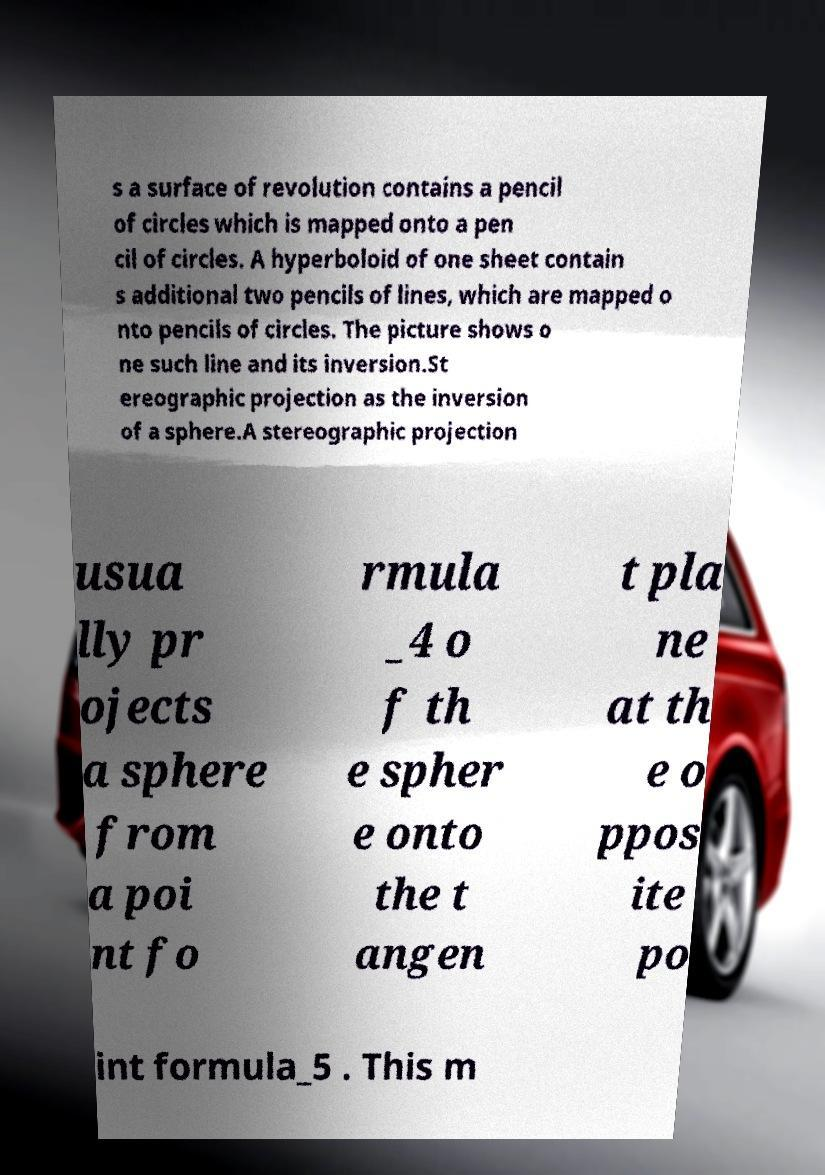What messages or text are displayed in this image? I need them in a readable, typed format. s a surface of revolution contains a pencil of circles which is mapped onto a pen cil of circles. A hyperboloid of one sheet contain s additional two pencils of lines, which are mapped o nto pencils of circles. The picture shows o ne such line and its inversion.St ereographic projection as the inversion of a sphere.A stereographic projection usua lly pr ojects a sphere from a poi nt fo rmula _4 o f th e spher e onto the t angen t pla ne at th e o ppos ite po int formula_5 . This m 